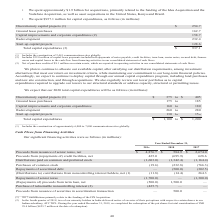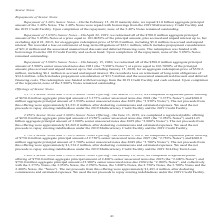According to American Tower Corporation's financial document, What were the net Proceeds from issuance of senior notes in 2019? According to the financial document, $4,876.7 (in millions). The relevant text states: "Proceeds from issuance of senior notes, net $ 4,876.7 $ 584.9 $ 2,674.0..." Also, What were the net Proceeds from (repayments of) credit facilities in 2018? According to the financial document, (695.9) (in millions). The relevant text states: "from (repayments of) credit facilities, net 425.0 (695.9) 628.6..." Also, What were the Distributions paid on common and preferred stock in 2017? According to the financial document, (1,164.4) (in millions). The relevant text states: "on common and preferred stock (1,603.0) (1,342.4) (1,164.4)..." Also, can you calculate: What was the change in Purchases of common stock between 2018 and 2019? Based on the calculation: -19.6-(-232.8), the result is 213.2 (in millions). This is based on the information: "Purchases of common stock (19.6) (232.8) (766.3) Purchases of common stock (19.6) (232.8) (766.3)..." The key data points involved are: 19.6, 232.8. Also, can you calculate: What was the change in net (Distributions to) contributions from noncontrolling interest holders between 2017 and 2018? Based on the calculation: -14.4-264.3, the result is -278.7 (in millions). This is based on the information: "ntrolling interest holders, net (1) (11.8) (14.4) 264.3 noncontrolling interest holders, net (1) (11.8) (14.4) 264.3..." The key data points involved are: 14.4, 264.3. Also, can you calculate: What was the percentage change in the net Proceeds from issuance of senior notes between 2018 and 2019? To answer this question, I need to perform calculations using the financial data. The calculation is: ($4,876.7-$584.9)/$584.9, which equals 733.77 (percentage). This is based on the information: "ds from issuance of senior notes, net $ 4,876.7 $ 584.9 $ 2,674.0 Proceeds from issuance of senior notes, net $ 4,876.7 $ 584.9 $ 2,674.0..." The key data points involved are: 4,876.7, 584.9. 